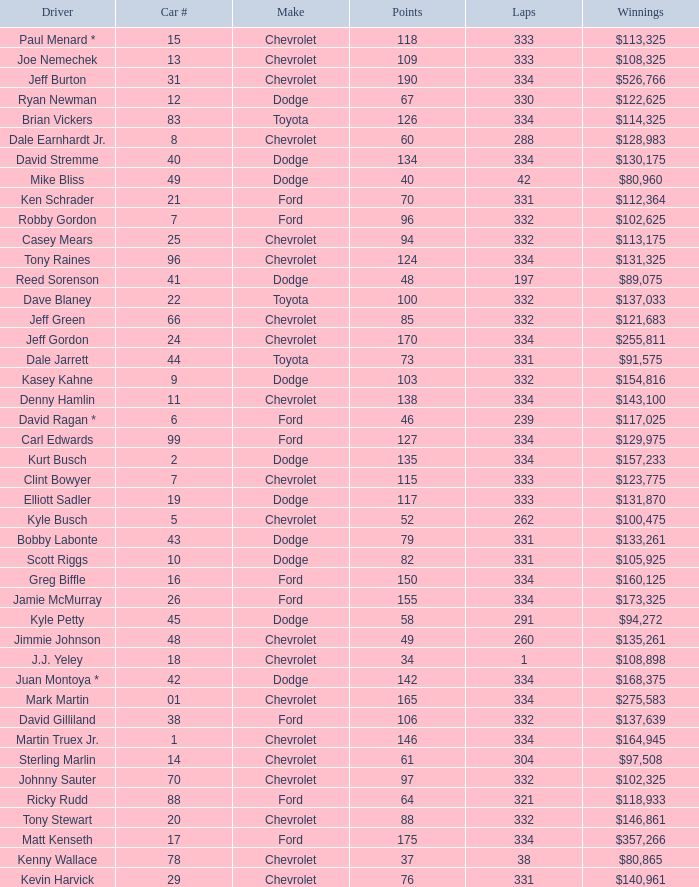How many total laps did the Chevrolet that won $97,508 make? 1.0. 